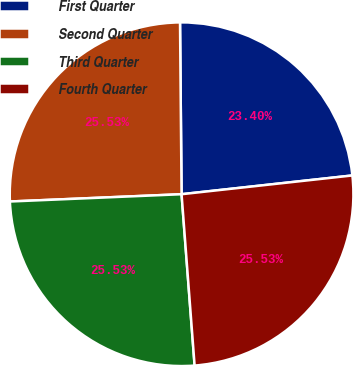Convert chart. <chart><loc_0><loc_0><loc_500><loc_500><pie_chart><fcel>First Quarter<fcel>Second Quarter<fcel>Third Quarter<fcel>Fourth Quarter<nl><fcel>23.4%<fcel>25.53%<fcel>25.53%<fcel>25.53%<nl></chart> 